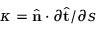Convert formula to latex. <formula><loc_0><loc_0><loc_500><loc_500>\kappa = \hat { n } \cdot { \partial \hat { t } } / { \partial s }</formula> 